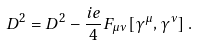<formula> <loc_0><loc_0><loc_500><loc_500>\ D ^ { 2 } = D ^ { 2 } - \frac { i e } { 4 } F _ { \mu \nu } [ \gamma ^ { \mu } , \gamma ^ { \nu } ] \, .</formula> 